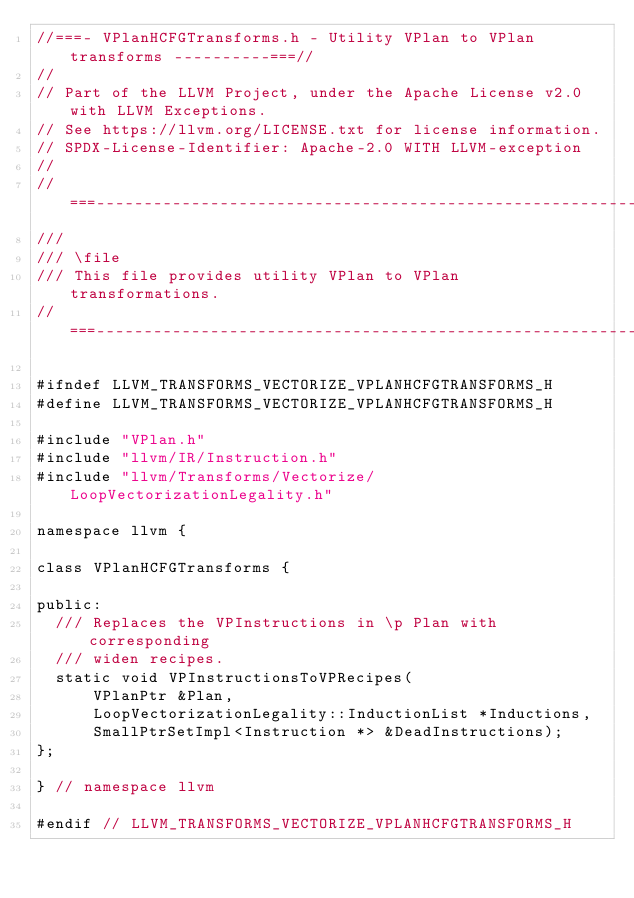Convert code to text. <code><loc_0><loc_0><loc_500><loc_500><_C_>//===- VPlanHCFGTransforms.h - Utility VPlan to VPlan transforms ----------===//
//
// Part of the LLVM Project, under the Apache License v2.0 with LLVM Exceptions.
// See https://llvm.org/LICENSE.txt for license information.
// SPDX-License-Identifier: Apache-2.0 WITH LLVM-exception
//
//===----------------------------------------------------------------------===//
///
/// \file
/// This file provides utility VPlan to VPlan transformations.
//===----------------------------------------------------------------------===//

#ifndef LLVM_TRANSFORMS_VECTORIZE_VPLANHCFGTRANSFORMS_H
#define LLVM_TRANSFORMS_VECTORIZE_VPLANHCFGTRANSFORMS_H

#include "VPlan.h"
#include "llvm/IR/Instruction.h"
#include "llvm/Transforms/Vectorize/LoopVectorizationLegality.h"

namespace llvm {

class VPlanHCFGTransforms {

public:
  /// Replaces the VPInstructions in \p Plan with corresponding
  /// widen recipes.
  static void VPInstructionsToVPRecipes(
      VPlanPtr &Plan,
      LoopVectorizationLegality::InductionList *Inductions,
      SmallPtrSetImpl<Instruction *> &DeadInstructions);
};

} // namespace llvm

#endif // LLVM_TRANSFORMS_VECTORIZE_VPLANHCFGTRANSFORMS_H
</code> 